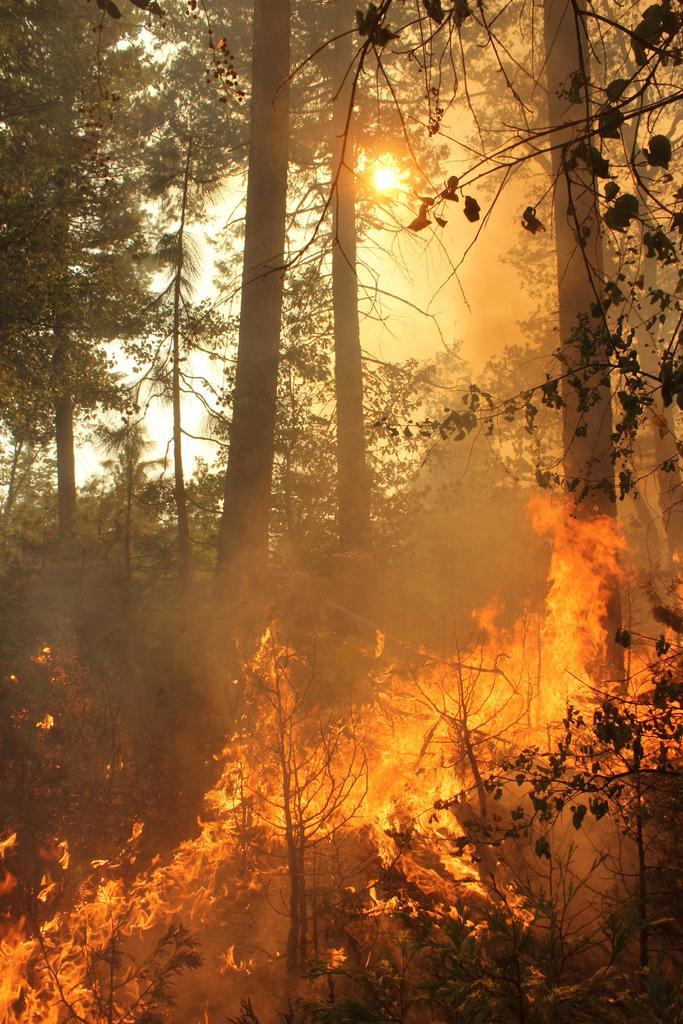What is happening to the trees in the image? There is fire on the trees in the image. What can be seen in the background of the image? There are trees and the sky visible in the background. What is the condition of the sky in the image? The sky is visible in the background, and the sun is present. How does the idea help to put out the fire in the image? There is no mention of an idea or any attempt to put out the fire in the image. The focus is solely on the presence of fire on the trees. 